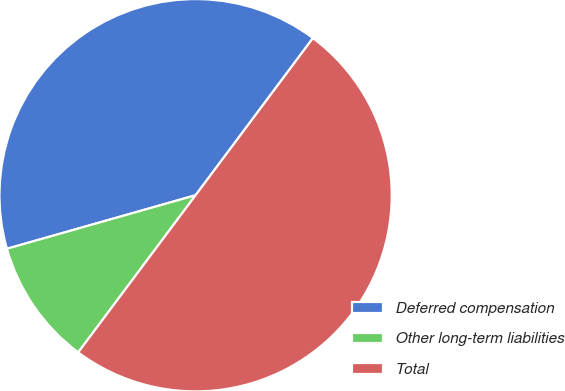Convert chart. <chart><loc_0><loc_0><loc_500><loc_500><pie_chart><fcel>Deferred compensation<fcel>Other long-term liabilities<fcel>Total<nl><fcel>39.61%<fcel>10.39%<fcel>50.0%<nl></chart> 